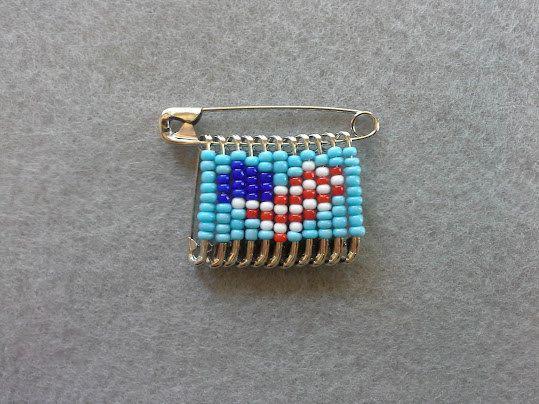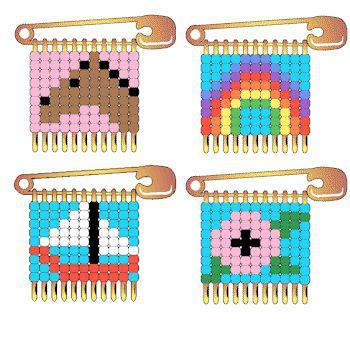The first image is the image on the left, the second image is the image on the right. Analyze the images presented: Is the assertion "There are at least four pins in one of the images." valid? Answer yes or no. Yes. 